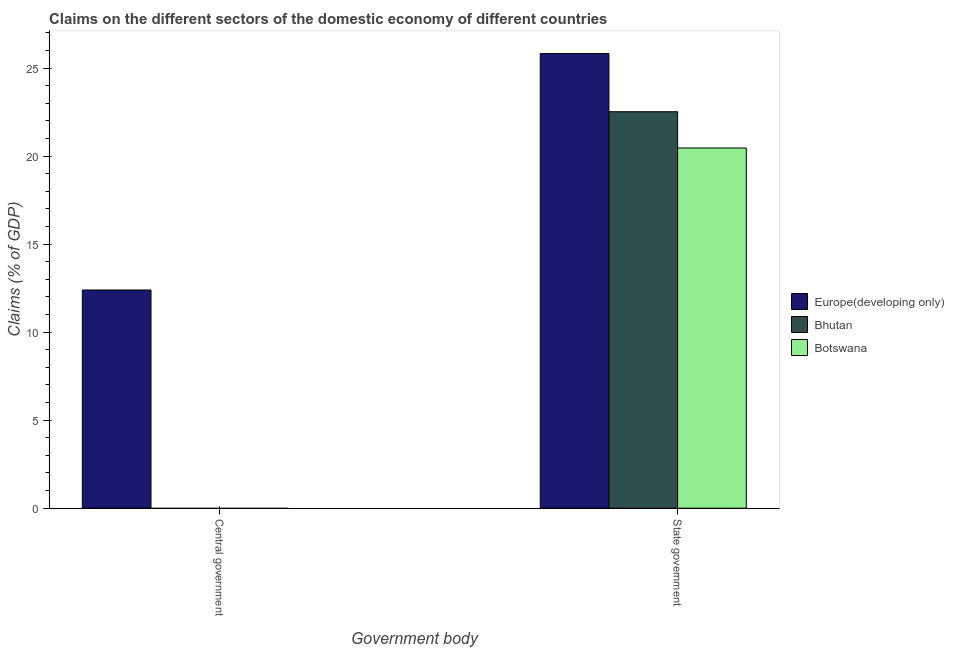Are the number of bars on each tick of the X-axis equal?
Make the answer very short. No. How many bars are there on the 2nd tick from the right?
Provide a succinct answer. 1. What is the label of the 1st group of bars from the left?
Your answer should be compact. Central government. What is the claims on central government in Europe(developing only)?
Offer a terse response. 12.39. Across all countries, what is the maximum claims on central government?
Give a very brief answer. 12.39. In which country was the claims on state government maximum?
Your response must be concise. Europe(developing only). What is the total claims on central government in the graph?
Your answer should be very brief. 12.39. What is the difference between the claims on state government in Botswana and that in Bhutan?
Keep it short and to the point. -2.06. What is the difference between the claims on central government in Europe(developing only) and the claims on state government in Botswana?
Make the answer very short. -8.07. What is the average claims on central government per country?
Ensure brevity in your answer.  4.13. What is the difference between the claims on state government and claims on central government in Europe(developing only)?
Make the answer very short. 13.43. What is the ratio of the claims on state government in Bhutan to that in Botswana?
Ensure brevity in your answer.  1.1. Is the claims on state government in Europe(developing only) less than that in Bhutan?
Your answer should be compact. No. How many bars are there?
Your response must be concise. 4. Are all the bars in the graph horizontal?
Ensure brevity in your answer.  No. What is the difference between two consecutive major ticks on the Y-axis?
Give a very brief answer. 5. Does the graph contain any zero values?
Ensure brevity in your answer.  Yes. Does the graph contain grids?
Your answer should be compact. No. What is the title of the graph?
Provide a short and direct response. Claims on the different sectors of the domestic economy of different countries. Does "Turkmenistan" appear as one of the legend labels in the graph?
Your answer should be very brief. No. What is the label or title of the X-axis?
Keep it short and to the point. Government body. What is the label or title of the Y-axis?
Make the answer very short. Claims (% of GDP). What is the Claims (% of GDP) of Europe(developing only) in Central government?
Provide a short and direct response. 12.39. What is the Claims (% of GDP) of Bhutan in Central government?
Make the answer very short. 0. What is the Claims (% of GDP) in Botswana in Central government?
Ensure brevity in your answer.  0. What is the Claims (% of GDP) of Europe(developing only) in State government?
Your answer should be compact. 25.82. What is the Claims (% of GDP) in Bhutan in State government?
Offer a terse response. 22.52. What is the Claims (% of GDP) of Botswana in State government?
Provide a short and direct response. 20.46. Across all Government body, what is the maximum Claims (% of GDP) in Europe(developing only)?
Your answer should be very brief. 25.82. Across all Government body, what is the maximum Claims (% of GDP) in Bhutan?
Your answer should be very brief. 22.52. Across all Government body, what is the maximum Claims (% of GDP) of Botswana?
Offer a very short reply. 20.46. Across all Government body, what is the minimum Claims (% of GDP) in Europe(developing only)?
Offer a terse response. 12.39. Across all Government body, what is the minimum Claims (% of GDP) of Botswana?
Your answer should be compact. 0. What is the total Claims (% of GDP) in Europe(developing only) in the graph?
Provide a short and direct response. 38.22. What is the total Claims (% of GDP) of Bhutan in the graph?
Provide a succinct answer. 22.52. What is the total Claims (% of GDP) in Botswana in the graph?
Your response must be concise. 20.46. What is the difference between the Claims (% of GDP) of Europe(developing only) in Central government and that in State government?
Keep it short and to the point. -13.43. What is the difference between the Claims (% of GDP) of Europe(developing only) in Central government and the Claims (% of GDP) of Bhutan in State government?
Ensure brevity in your answer.  -10.13. What is the difference between the Claims (% of GDP) of Europe(developing only) in Central government and the Claims (% of GDP) of Botswana in State government?
Make the answer very short. -8.07. What is the average Claims (% of GDP) of Europe(developing only) per Government body?
Your response must be concise. 19.11. What is the average Claims (% of GDP) of Bhutan per Government body?
Provide a succinct answer. 11.26. What is the average Claims (% of GDP) of Botswana per Government body?
Offer a very short reply. 10.23. What is the difference between the Claims (% of GDP) of Europe(developing only) and Claims (% of GDP) of Bhutan in State government?
Provide a short and direct response. 3.3. What is the difference between the Claims (% of GDP) of Europe(developing only) and Claims (% of GDP) of Botswana in State government?
Keep it short and to the point. 5.36. What is the difference between the Claims (% of GDP) of Bhutan and Claims (% of GDP) of Botswana in State government?
Offer a terse response. 2.06. What is the ratio of the Claims (% of GDP) in Europe(developing only) in Central government to that in State government?
Ensure brevity in your answer.  0.48. What is the difference between the highest and the second highest Claims (% of GDP) of Europe(developing only)?
Make the answer very short. 13.43. What is the difference between the highest and the lowest Claims (% of GDP) of Europe(developing only)?
Ensure brevity in your answer.  13.43. What is the difference between the highest and the lowest Claims (% of GDP) in Bhutan?
Offer a very short reply. 22.52. What is the difference between the highest and the lowest Claims (% of GDP) in Botswana?
Ensure brevity in your answer.  20.46. 